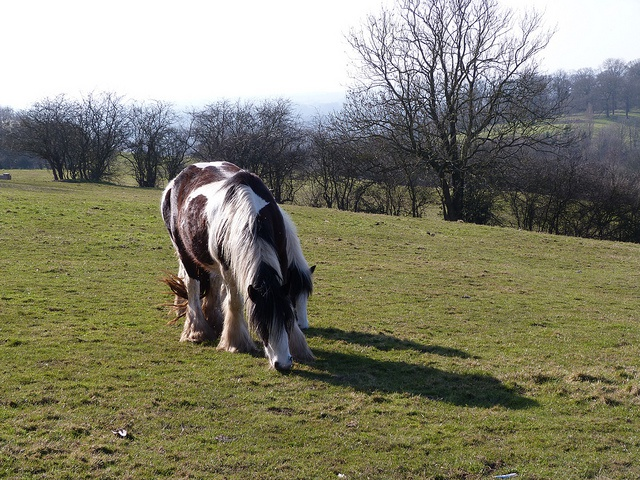Describe the objects in this image and their specific colors. I can see a horse in white, black, gray, lightgray, and darkgray tones in this image. 